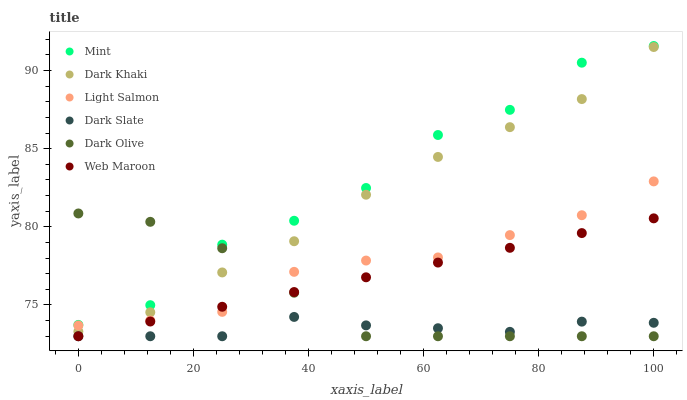Does Dark Slate have the minimum area under the curve?
Answer yes or no. Yes. Does Mint have the maximum area under the curve?
Answer yes or no. Yes. Does Dark Olive have the minimum area under the curve?
Answer yes or no. No. Does Dark Olive have the maximum area under the curve?
Answer yes or no. No. Is Web Maroon the smoothest?
Answer yes or no. Yes. Is Mint the roughest?
Answer yes or no. Yes. Is Dark Olive the smoothest?
Answer yes or no. No. Is Dark Olive the roughest?
Answer yes or no. No. Does Dark Olive have the lowest value?
Answer yes or no. Yes. Does Dark Khaki have the lowest value?
Answer yes or no. No. Does Mint have the highest value?
Answer yes or no. Yes. Does Dark Olive have the highest value?
Answer yes or no. No. Is Web Maroon less than Mint?
Answer yes or no. Yes. Is Dark Khaki greater than Dark Slate?
Answer yes or no. Yes. Does Dark Olive intersect Mint?
Answer yes or no. Yes. Is Dark Olive less than Mint?
Answer yes or no. No. Is Dark Olive greater than Mint?
Answer yes or no. No. Does Web Maroon intersect Mint?
Answer yes or no. No. 